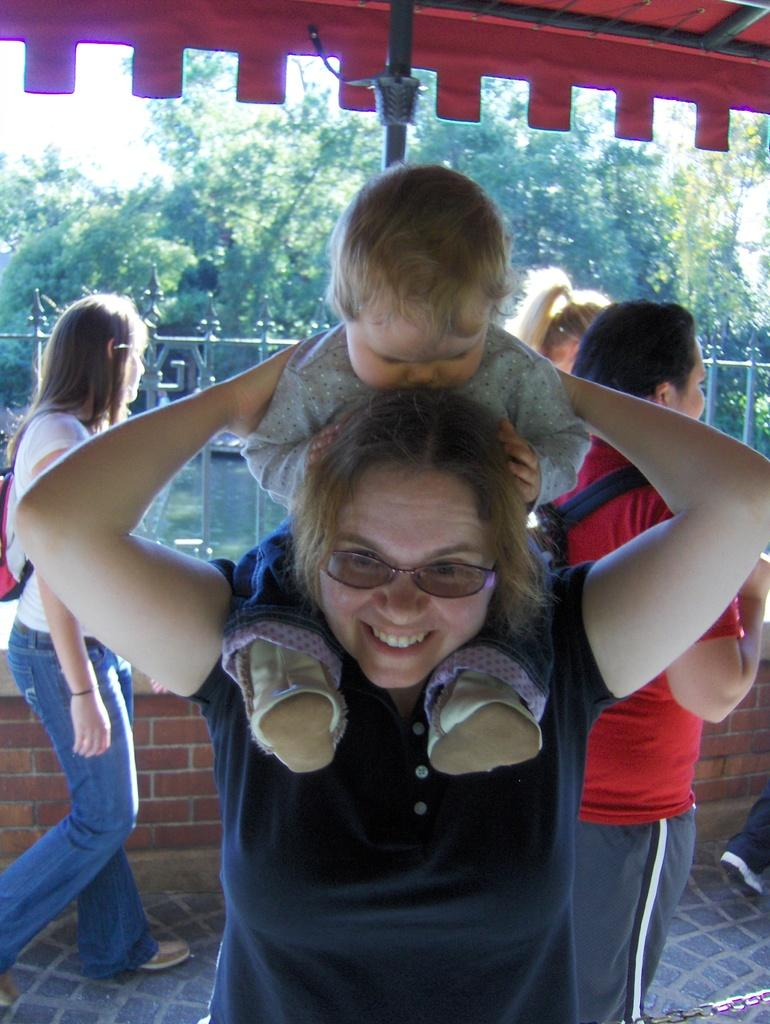How many people are in the image? There are four persons in the image. Where are the persons located in the image? The persons are on the floor and fence. What can be seen in the background of the image? There is water, trees, a tent, and the sky visible in the background of the image. What is the weather like in the image? The image appears to have been taken during a sunny day. What type of steel structure can be seen in the image? There is no steel structure present in the image. Can you tell me how many basketballs are visible in the image? There are no basketballs visible in the image. 